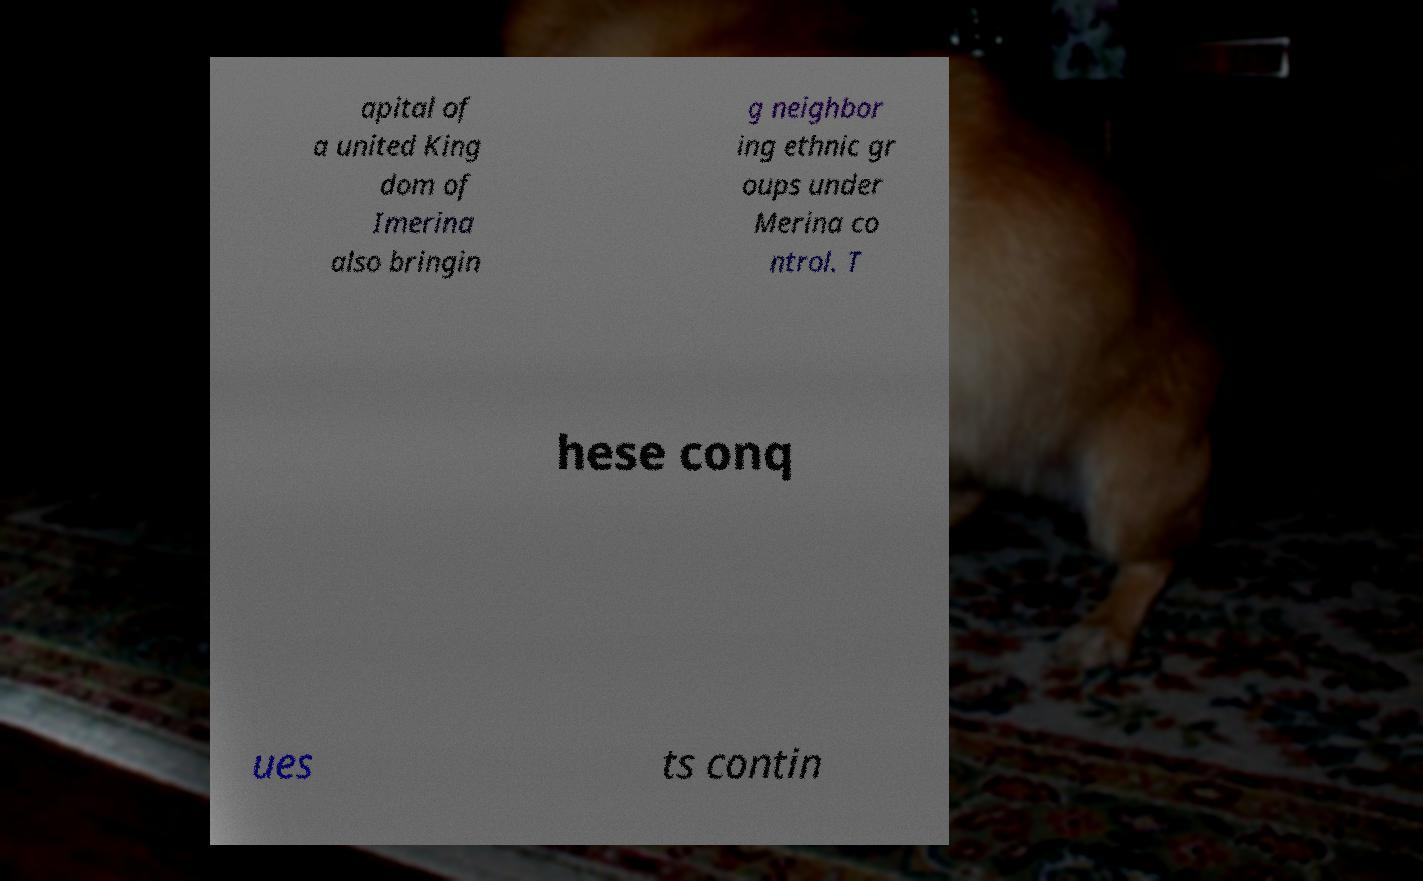Please read and relay the text visible in this image. What does it say? apital of a united King dom of Imerina also bringin g neighbor ing ethnic gr oups under Merina co ntrol. T hese conq ues ts contin 